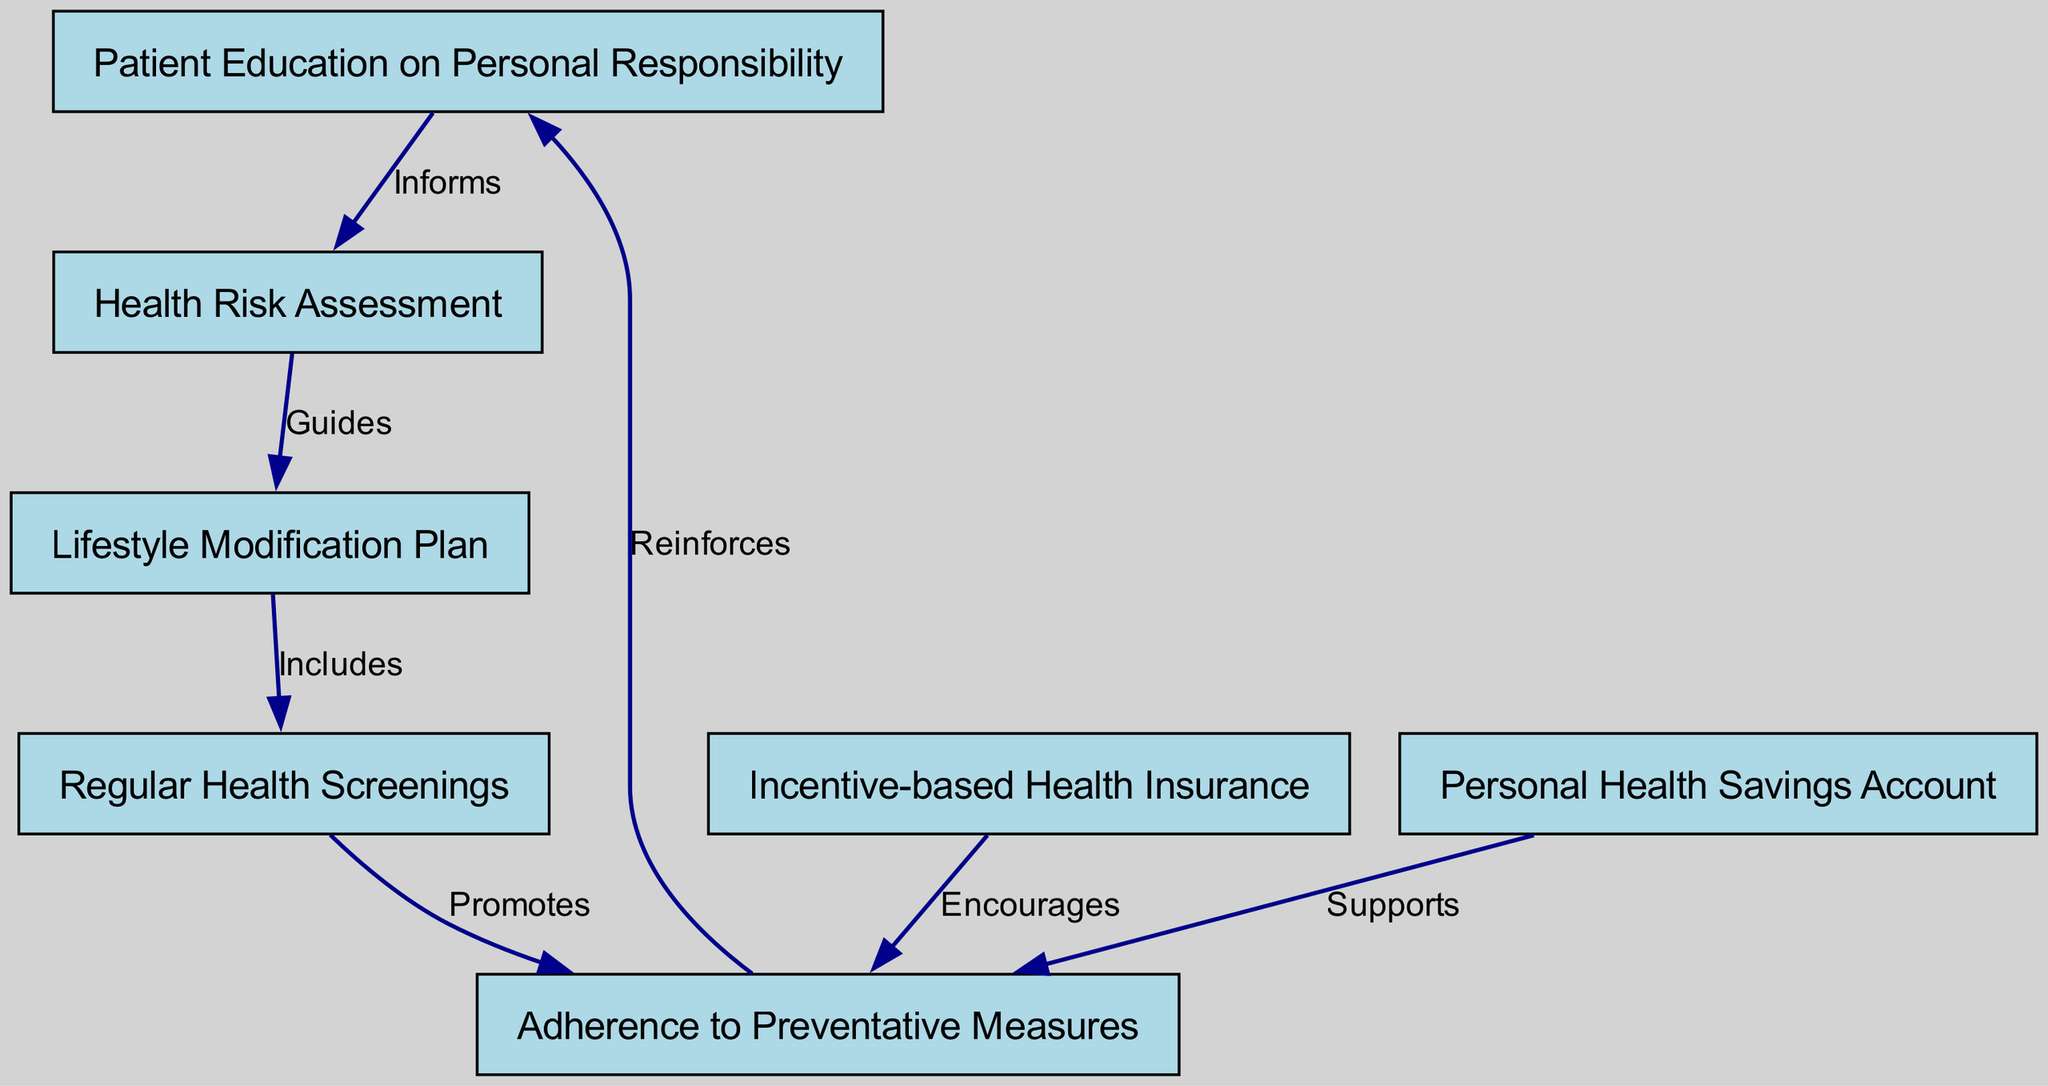What is the first node in the diagram? The first node in the diagram is identified by the number and is labeled as "Patient Education on Personal Responsibility." It appears at the top of the flow, establishing the foundational concept for the pathway.
Answer: Patient Education on Personal Responsibility How many nodes are there in total? By counting the nodes listed in the data, there are seven distinct nodes present in the diagram. Each node represents a key component of the clinical pathway described.
Answer: 7 What relationship exists between "Health Risk Assessment" and "Lifestyle Modification Plan"? The relationship between these two nodes is described by the edge that states "Guides," indicating that the "Health Risk Assessment" leads to or informs the creation of the "Lifestyle Modification Plan."
Answer: Guides What is the final outcome of the pathway as indicated by the last node? The final node in the pathway is "Adherence to Preventative Measures," which suggests that the pathway aims to promote consistent engagement in health-preserving activities.
Answer: Adherence to Preventative Measures Which node supports adherence to preventative measures? The node labeled "Personal Health Savings Account" has an edge directed to "Adherence to Preventative Measures," indicating that it provides support for individuals striving to maintain their health through preventative measures.
Answer: Personal Health Savings Account What promotes regular health screenings according to the diagram? The relationship "Promotes" connects the "Regular Health Screenings" node to "Adherence to Preventative Measures," indicating that the act of having regular health screenings encourages the maintenance of prevention practices.
Answer: Promotes Which node reinforces the concept of personal responsibility? The "Adherence to Preventative Measures" node has an edge leading back to "Patient Education on Personal Responsibility," indicating that it reinforces the need for personal responsibility in managing health.
Answer: Adherence to Preventative Measures 